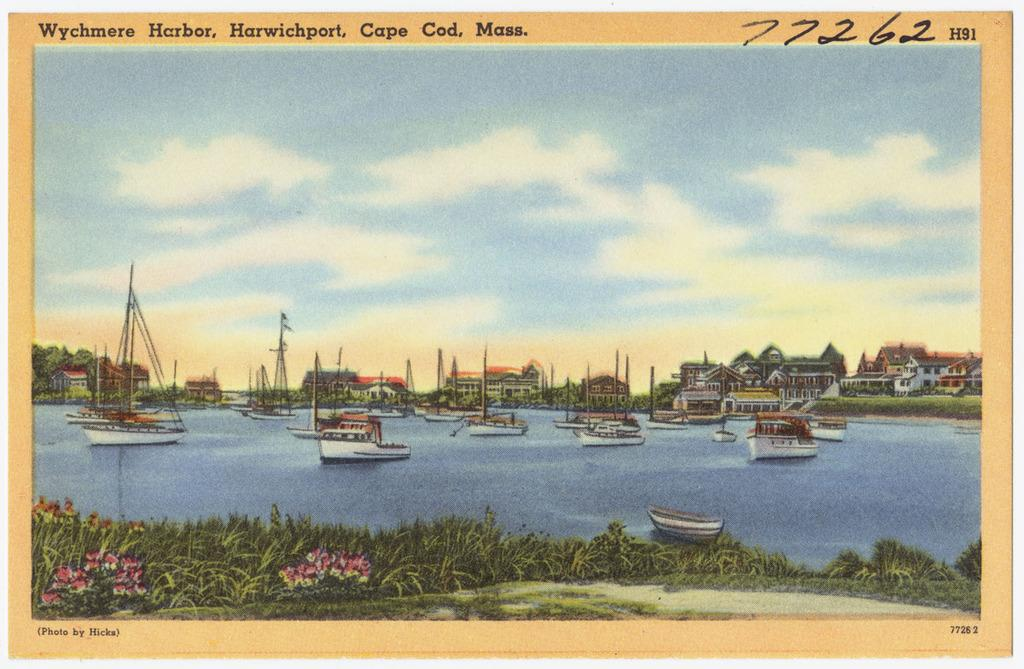<image>
Present a compact description of the photo's key features. A painting of a bay full of boats in Cape Code, Mass. 